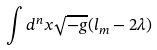<formula> <loc_0><loc_0><loc_500><loc_500>\int { d ^ { n } x \sqrt { - g } ( l _ { m } - 2 \lambda ) }</formula> 